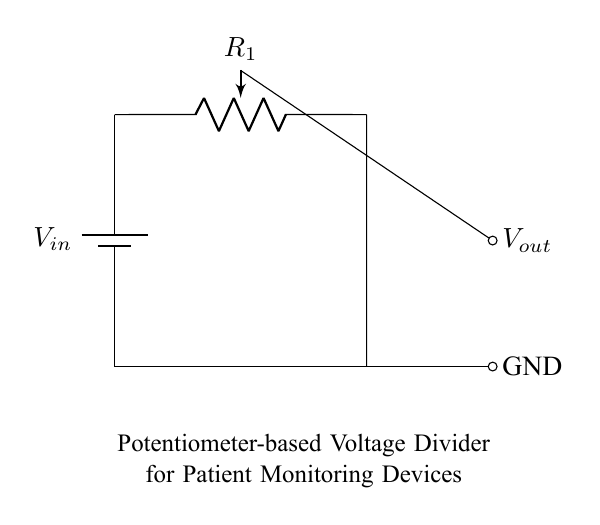What type of circuit is shown? This is a voltage divider circuit, which is used to create a lower voltage from a higher voltage using resistive elements. In this case, it employs a potentiometer to adjust the output voltage.
Answer: Voltage divider What is the function of the potentiometer in this circuit? The potentiometer acts as a variable resistor, allowing users to adjust the resistance and therefore the output voltage. This is crucial for calibrating patient monitoring devices based on the specific requirements of the device or patient.
Answer: Adjust output voltage What are the two voltage points indicated in the circuit? The circuit shows two voltage points: the input voltage, which is labeled \( V_{in} \), and the output voltage, labeled \( V_{out} \). The difference between these voltages is essential in defining the function of the divider.
Answer: Vin and Vout What completes the circuit at the ground level? The circuit is completed at the ground level by connecting the lower end of the voltage divider to the ground, which provides a reference point for measuring \( V_{out} \) and ensures the circuit operates correctly.
Answer: Ground What is the primary application of this circuit in patient monitoring devices? The primary application of the potentiometer-based voltage divider in patient monitoring devices is to provide adjustable voltage levels that correspond to different sensor readings or calibrate the device for accurate measurements.
Answer: To calibrate readings 